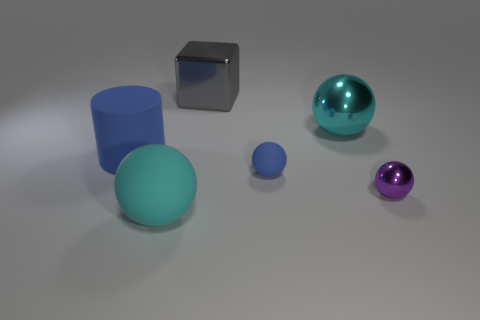Is the color of the cylinder the same as the small rubber object?
Ensure brevity in your answer.  Yes. Is there any other thing that is the same color as the matte cylinder?
Provide a succinct answer. Yes. There is a cyan thing that is right of the small blue rubber ball; are there any large cyan spheres that are in front of it?
Your answer should be very brief. Yes. How many gray shiny objects are on the right side of the big cyan ball in front of the big cyan ball on the right side of the big gray metal cube?
Provide a succinct answer. 1. Are there fewer cyan balls than tiny rubber objects?
Your answer should be compact. No. There is a cyan object that is to the right of the small blue ball; is its shape the same as the big rubber thing behind the small purple shiny object?
Provide a short and direct response. No. What color is the cylinder?
Make the answer very short. Blue. What number of metallic things are blue things or brown things?
Make the answer very short. 0. There is another shiny object that is the same shape as the tiny shiny object; what is its color?
Your answer should be very brief. Cyan. Is there a large blue cube?
Your response must be concise. No. 